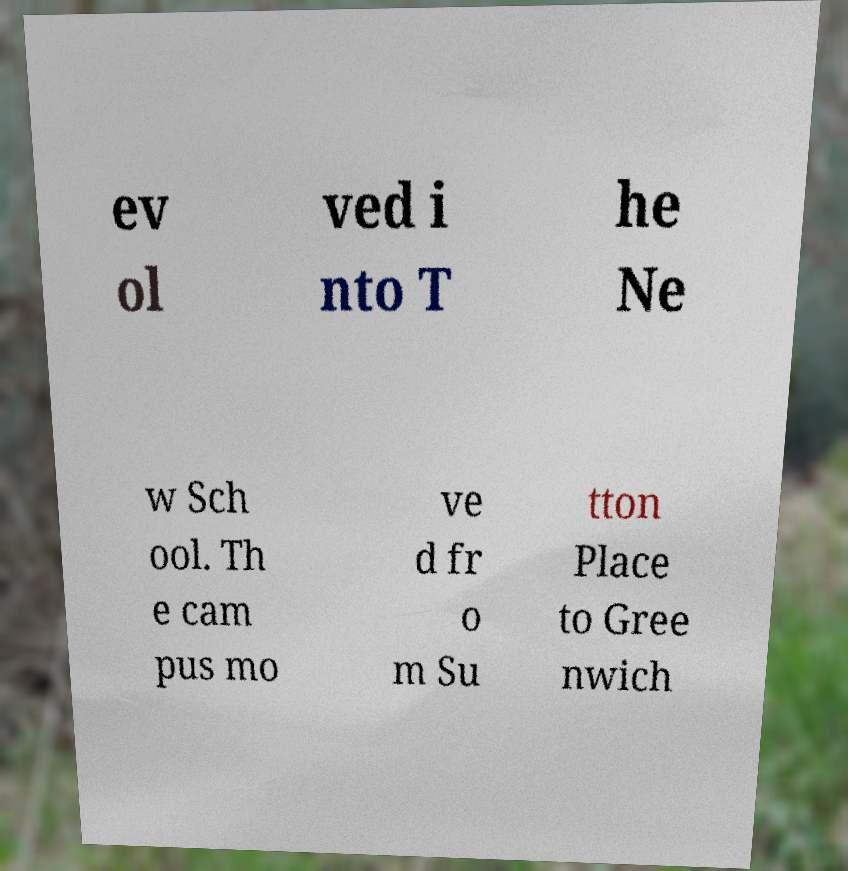Can you read and provide the text displayed in the image?This photo seems to have some interesting text. Can you extract and type it out for me? ev ol ved i nto T he Ne w Sch ool. Th e cam pus mo ve d fr o m Su tton Place to Gree nwich 